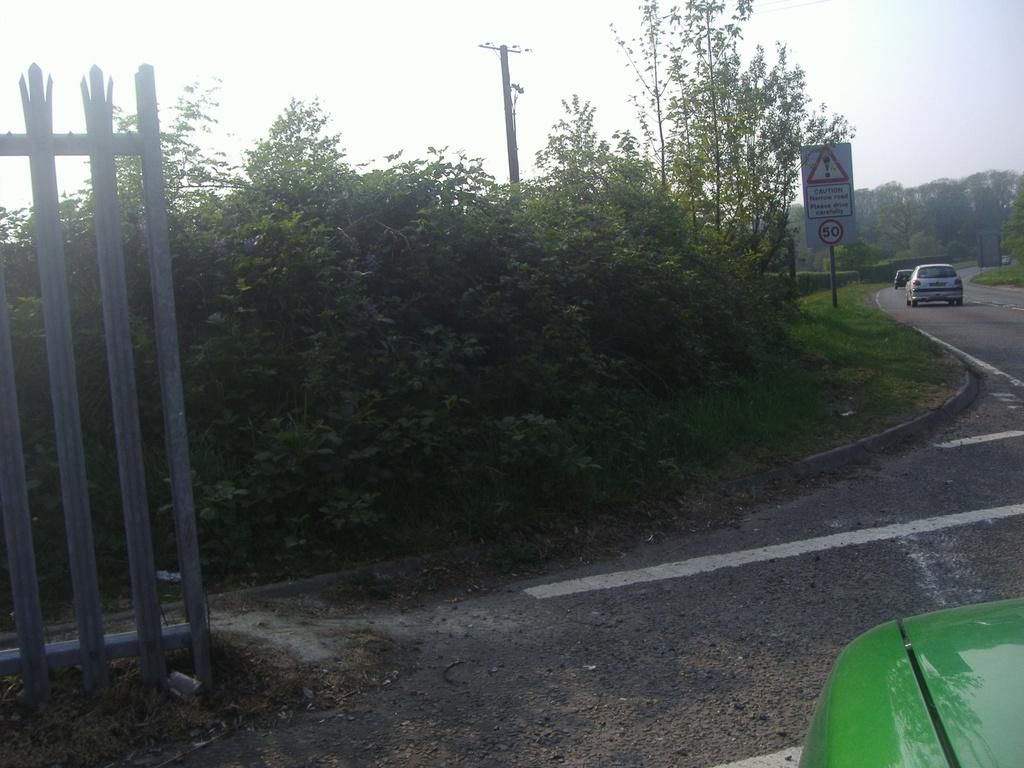What is located in the center of the image? There are trees and a board in the center of the image. What can be seen on the left side of the image? There is a fence on the left side of the image. What type of vehicles are visible in the image? Cars are visible on the road in the image. What is present in the image besides the trees, board, fence, and cars? There is a pole in the image. What is visible in the background of the image? The sky is visible in the background of the image. Where is the throne located in the image? There is no throne present in the image. What type of drink is being served in the image? There is no drink, such as eggnog, present in the image. 